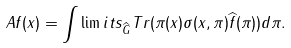<formula> <loc_0><loc_0><loc_500><loc_500>A f ( x ) = \int \lim i t s _ { \widehat { G } } T r ( \pi ( x ) \sigma ( x , \pi ) \widehat { f } ( \pi ) ) d \pi .</formula> 